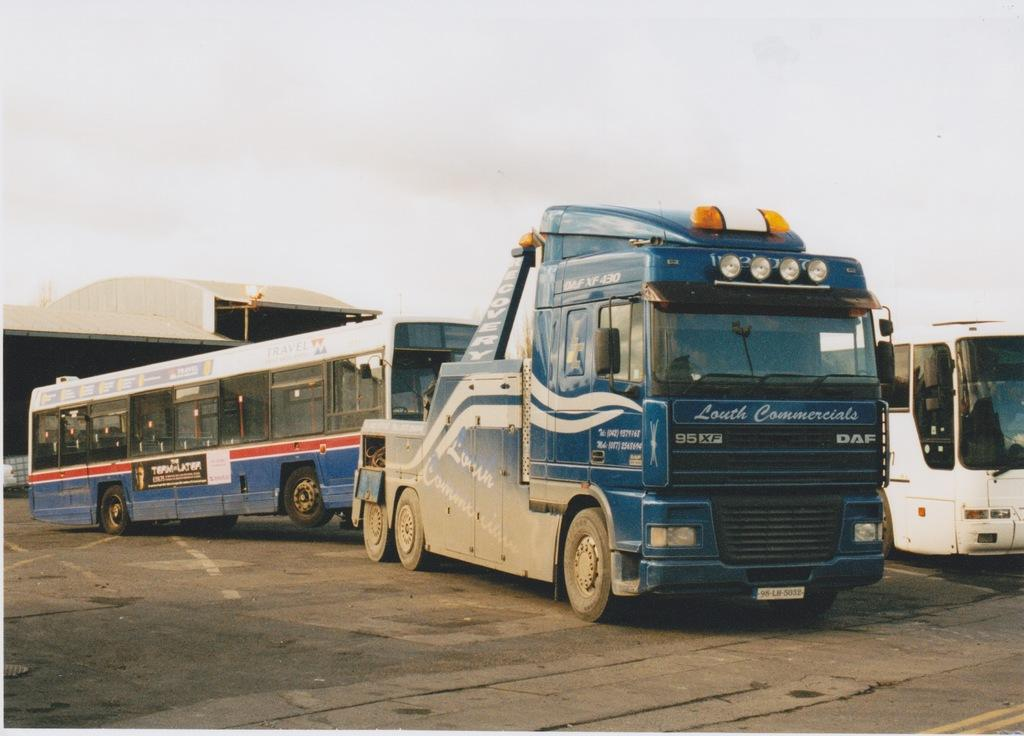What type of vehicle is in the image? There is a blue truck in the image. What is the truck doing in the image? The truck is towing a bus. What can be seen in the background of the image? There is a shed workshop in the background. What is visible at the top of the image? The sky is visible at the top of the image. Can you see any hair on the goat in the image? There is no goat present in the image, so it is not possible to see any hair on a goat. 